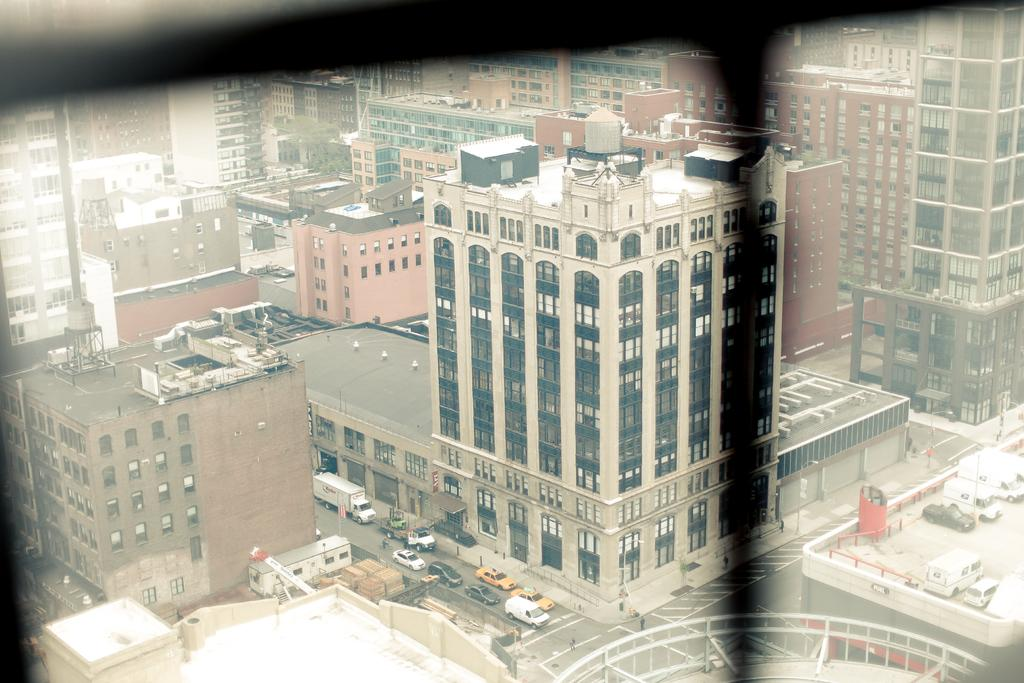What can be seen on the road in the image? There are vehicles on the road in the image. What type of structures are visible in the image? There are buildings visible in the image. What type of news can be seen on the mountain in the image? There is no mountain or news present in the image. What is being used to serve food on the tray in the image? There is no tray present in the image. 